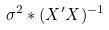<formula> <loc_0><loc_0><loc_500><loc_500>\sigma ^ { 2 } * ( X ^ { \prime } X ) ^ { - 1 }</formula> 